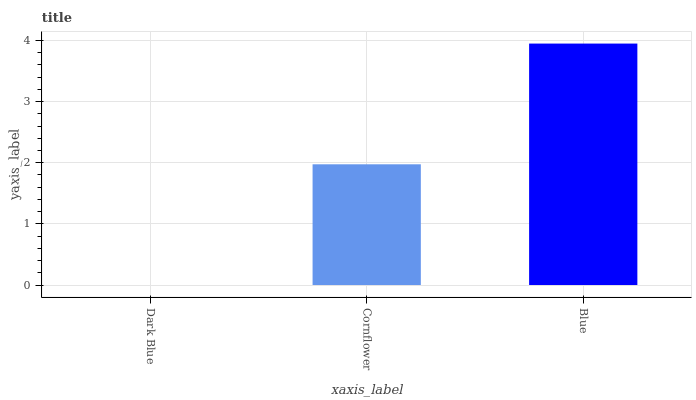Is Dark Blue the minimum?
Answer yes or no. Yes. Is Blue the maximum?
Answer yes or no. Yes. Is Cornflower the minimum?
Answer yes or no. No. Is Cornflower the maximum?
Answer yes or no. No. Is Cornflower greater than Dark Blue?
Answer yes or no. Yes. Is Dark Blue less than Cornflower?
Answer yes or no. Yes. Is Dark Blue greater than Cornflower?
Answer yes or no. No. Is Cornflower less than Dark Blue?
Answer yes or no. No. Is Cornflower the high median?
Answer yes or no. Yes. Is Cornflower the low median?
Answer yes or no. Yes. Is Blue the high median?
Answer yes or no. No. Is Blue the low median?
Answer yes or no. No. 